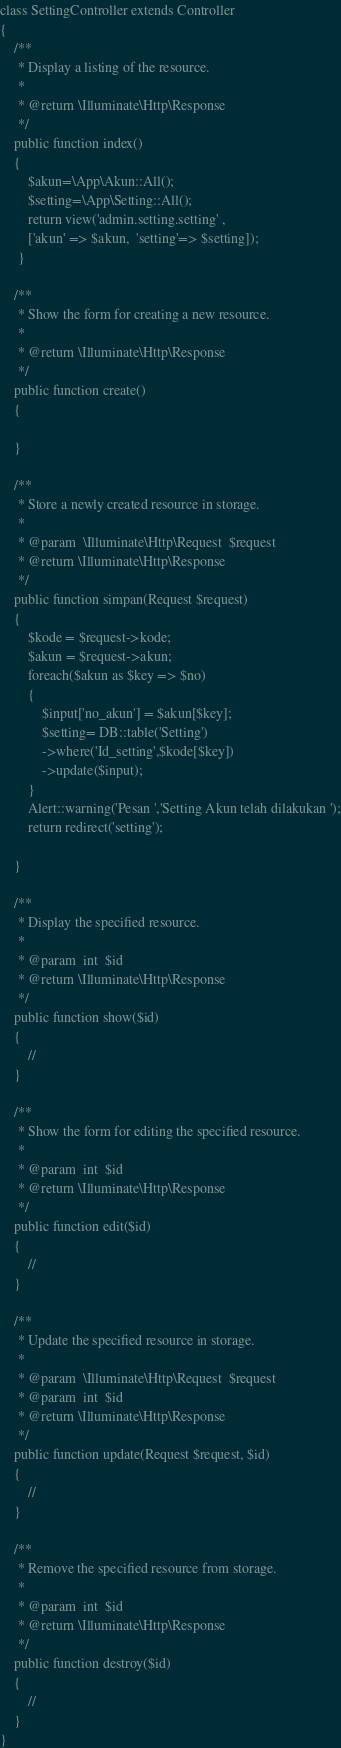Convert code to text. <code><loc_0><loc_0><loc_500><loc_500><_PHP_>class SettingController extends Controller
{
    /**
     * Display a listing of the resource.
     *
     * @return \Illuminate\Http\Response
     */
    public function index()
    {
        $akun=\App\Akun::All();
        $setting=\App\Setting::All();
        return view('admin.setting.setting' ,
        ['akun' => $akun,  'setting'=> $setting]);
     }

    /**
     * Show the form for creating a new resource.
     *
     * @return \Illuminate\Http\Response
     */
    public function create()
    {
        
    }

    /**
     * Store a newly created resource in storage.
     *
     * @param  \Illuminate\Http\Request  $request
     * @return \Illuminate\Http\Response
     */
    public function simpan(Request $request)
    {
        $kode = $request->kode;
        $akun = $request->akun;
        foreach($akun as $key => $no)
        {
            $input['no_akun'] = $akun[$key];
            $setting= DB::table('Setting')
            ->where('Id_setting',$kode[$key])
            ->update($input);
        }
        Alert::warning('Pesan ','Setting Akun telah dilakukan ');
        return redirect('setting');
           
    }

    /**
     * Display the specified resource.
     *
     * @param  int  $id
     * @return \Illuminate\Http\Response
     */
    public function show($id)
    {
        //
    }

    /**
     * Show the form for editing the specified resource.
     *
     * @param  int  $id
     * @return \Illuminate\Http\Response
     */
    public function edit($id)
    {
        //
    }

    /**
     * Update the specified resource in storage.
     *
     * @param  \Illuminate\Http\Request  $request
     * @param  int  $id
     * @return \Illuminate\Http\Response
     */
    public function update(Request $request, $id)
    {
        //
    }

    /**
     * Remove the specified resource from storage.
     *
     * @param  int  $id
     * @return \Illuminate\Http\Response
     */
    public function destroy($id)
    {
        //
    }
}
</code> 